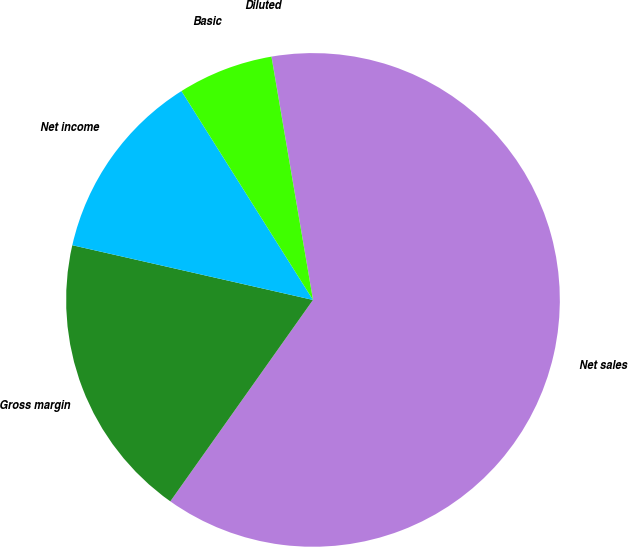Convert chart to OTSL. <chart><loc_0><loc_0><loc_500><loc_500><pie_chart><fcel>Net sales<fcel>Gross margin<fcel>Net income<fcel>Basic<fcel>Diluted<nl><fcel>62.49%<fcel>18.75%<fcel>12.5%<fcel>6.25%<fcel>0.01%<nl></chart> 